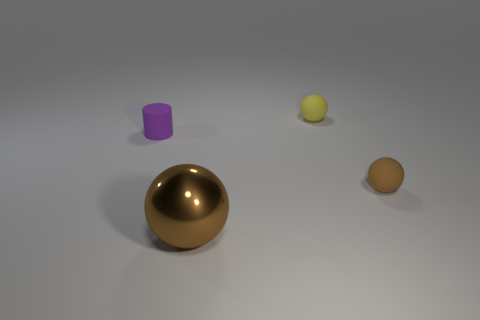What size is the matte thing that is the same color as the metal thing?
Give a very brief answer. Small. How many other things have the same color as the big metal object?
Provide a succinct answer. 1. There is a matte sphere that is in front of the rubber cylinder; how big is it?
Make the answer very short. Small. What shape is the thing that is the same color as the big sphere?
Offer a very short reply. Sphere. What shape is the yellow thing that is behind the small rubber thing that is in front of the purple rubber thing that is in front of the yellow matte ball?
Provide a succinct answer. Sphere. How many other objects are there of the same shape as the yellow matte object?
Make the answer very short. 2. What number of matte things are either yellow balls or cylinders?
Give a very brief answer. 2. What is the material of the brown thing that is on the left side of the brown sphere behind the metal ball?
Provide a short and direct response. Metal. Is the number of purple cylinders that are on the right side of the purple matte thing greater than the number of purple rubber things?
Offer a terse response. No. Are there any small purple cubes made of the same material as the small brown thing?
Provide a succinct answer. No. 